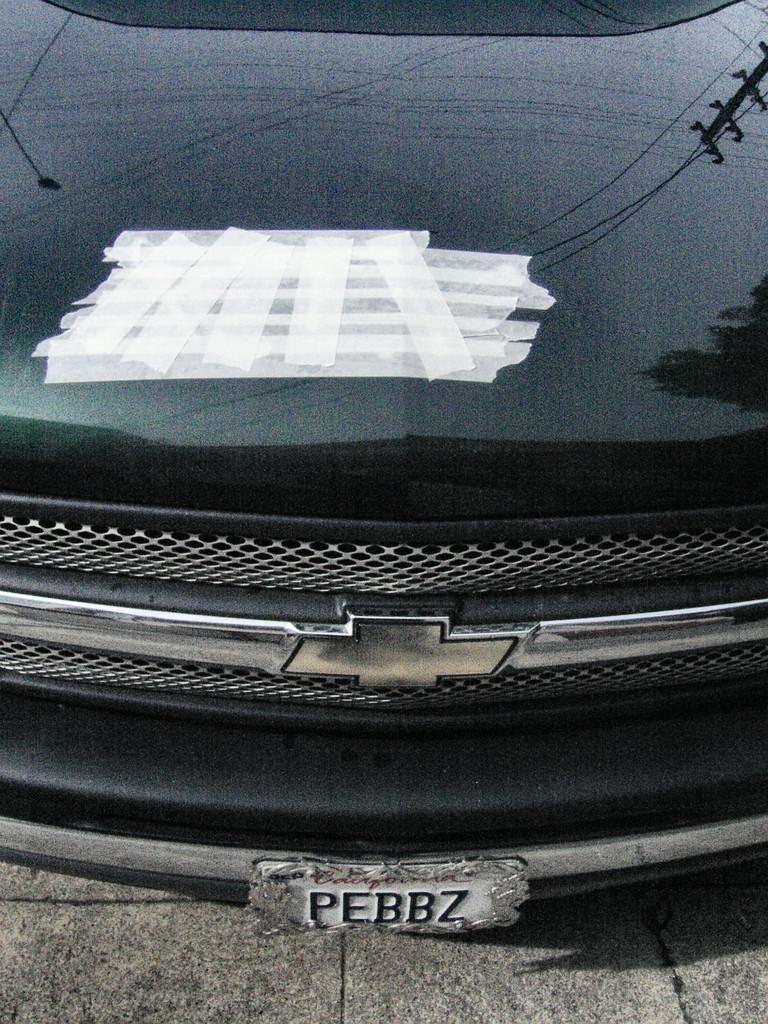What is the main subject of the image? The main subject of the image is a car. Where is the car located in the image? The car is on the ground in the image. What can be seen attached to the car? There are white plasters attached to the car. Can you hear the car's engine running in the image? The image is static, so it is not possible to hear any sounds, including the car's engine. 